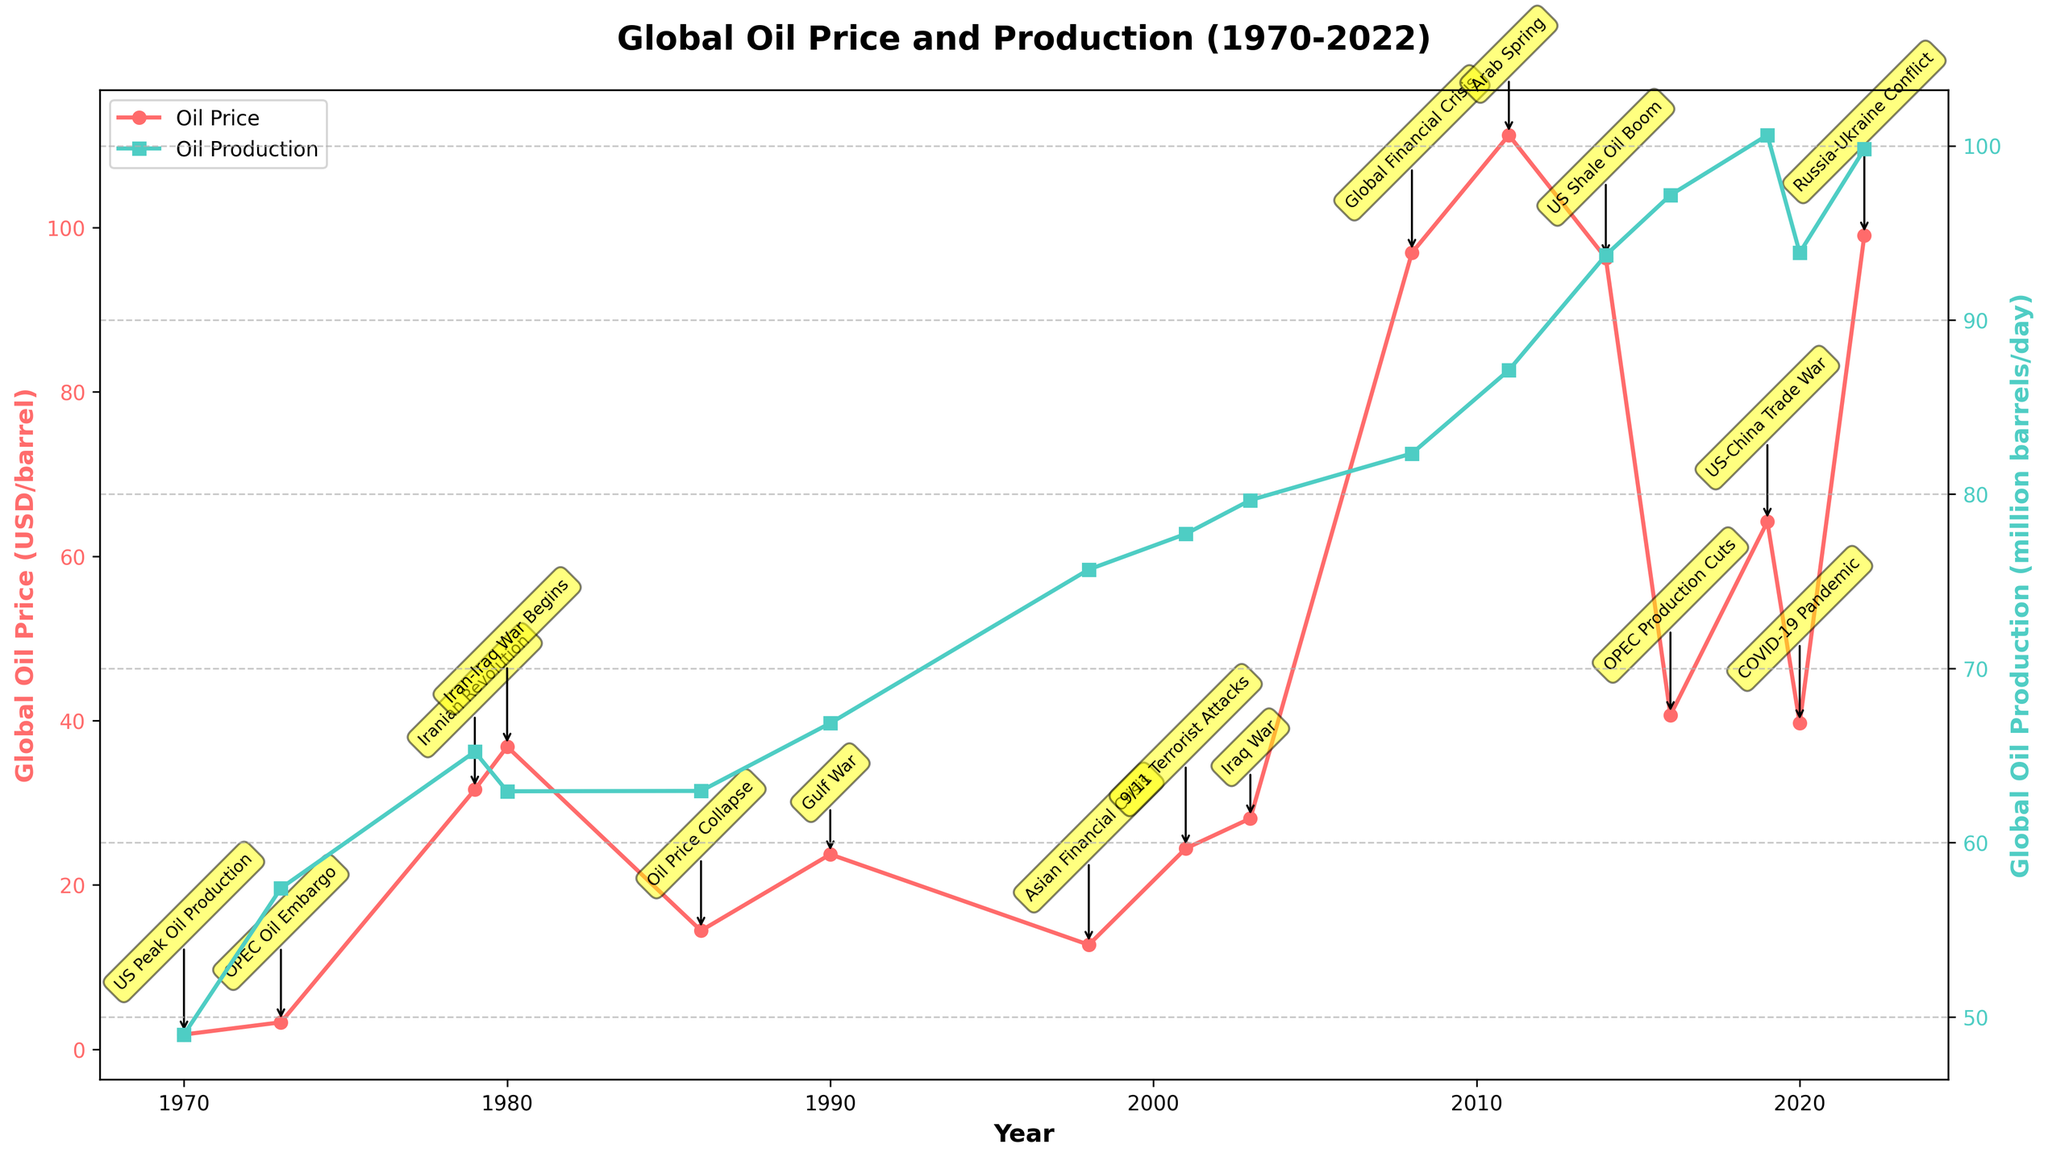What was the impact of the Iranian Revolution on global oil prices? The Iranian Revolution in 1979 caused a significant spike in oil prices, as shown by the sharp increase from around $3.29 per barrel in 1973 to $31.61 per barrel in 1979.
Answer: Sharp increase How did global oil production change during the 1973 OPEC Oil Embargo? During the 1973 OPEC Oil Embargo, global oil production increased from 48.99 million barrels/day in 1970 to 57.39 million barrels/day in 1973.
Answer: Increased Which event in the data is associated with the highest oil price observed between 1970 and 2022? The highest oil price observed between 1970 and 2022 is $111.26 per barrel during the Arab Spring in 2011.
Answer: Arab Spring in 2011 Compare the global oil production levels during the US Shale Oil Boom and the COVID-19 Pandemic. During the US Shale Oil Boom in 2014, global oil production was 93.72 million barrels/day. During the COVID-19 Pandemic in 2020, it was 93.86 million barrels/day. The production levels are very close, with a slight increase during the COVID-19 Pandemic.
Answer: Slight increase in 2020 What is the average global oil production during the 1980s (1980, 1986)? Average global oil production during the 1980s is calculated by taking the sum of production in 1980 (62.95 million barrels/day) and 1986 (62.97 million barrels/day) and then dividing by 2. (62.95 + 62.97)/2 = 62.96 million barrels/day.
Answer: 62.96 million barrels/day How much did the oil price fluctuate during the Global Financial Crisis compared to the Iraq War? During the Global Financial Crisis in 2008, the oil price was $96.94 per barrel. During the Iraq War in 2003, it was $28.10 per barrel. The fluctuation is calculated by the difference: $96.94 - $28.10 = $68.84 per barrel.
Answer: $68.84 per barrel What color represents global oil production levels on the plot? The plot uses green color to represent global oil production levels. The lines and markers associated with production are all in green.
Answer: Green How did global oil prices and production levels change after the 9/11 Terrorist Attacks? After the 9/11 Terrorist Attacks in 2001, oil prices increased from $24.44 in 2001 to $28.10 per barrel in 2003, while production increased from 77.72 million barrels/day in 2001 to 79.66 million barrels/day in 2003.
Answer: Both increased Which geopolitical event corresponded with a significant drop in oil prices? The Oil Price Collapse in 1986 corresponded with a significant drop in oil prices, falling from $36.83 per barrel in 1980 to $14.44 per barrel in 1986.
Answer: Oil Price Collapse in 1986 